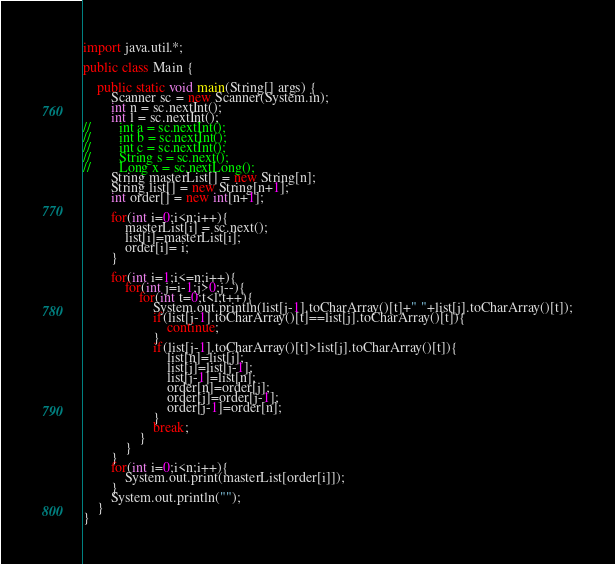Convert code to text. <code><loc_0><loc_0><loc_500><loc_500><_Java_>import java.util.*;

public class Main {

    public static void main(String[] args) {
        Scanner sc = new Scanner(System.in);
        int n = sc.nextInt();
        int l = sc.nextInt();
//        int a = sc.nextInt();
//        int b = sc.nextInt();
//        int c = sc.nextInt();
//        String s = sc.next();
//        Long x = sc.nextLong();
        String masterList[] = new String[n];
        String list[] = new String[n+1];
        int order[] = new int[n+1];

        for(int i=0;i<n;i++){
            masterList[i] = sc.next();
            list[i]=masterList[i];
            order[i]= i;
        }

        for(int i=1;i<=n;i++){
            for(int j=i-1;j>0;j--){
                for(int t=0;t<l;t++){
                    System.out.println(list[j-1].toCharArray()[t]+" "+list[j].toCharArray()[t]);
                    if(list[j-1].toCharArray()[t]==list[j].toCharArray()[t]){
                        continue;
                    }
                    if(list[j-1].toCharArray()[t]>list[j].toCharArray()[t]){
                        list[n]=list[j];
                        list[j]=list[j-1];
                        list[j-1]=list[n];
                        order[n]=order[j];
                        order[j]=order[j-1];
                        order[j-1]=order[n];
                    }
                    break;
                }
            }
        }
        for(int i=0;i<n;i++){
            System.out.print(masterList[order[i]]);
        }
        System.out.println("");
    }
}
</code> 